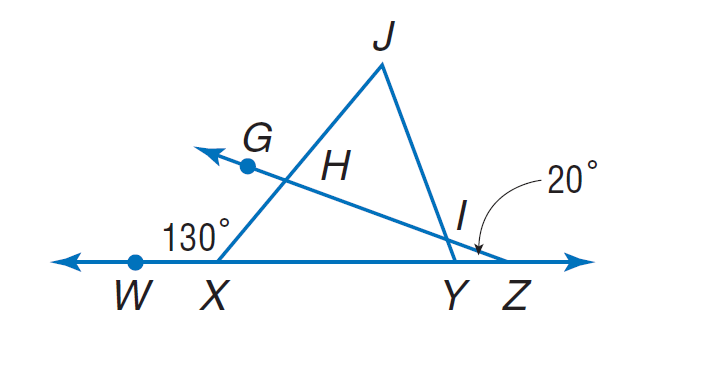Answer the mathemtical geometry problem and directly provide the correct option letter.
Question: If \frac { I J } { X J } = \frac { H J } { Y J }, m \angle W X J = 130 and m \angle W Z G = 20, find m \angle J H I.
Choices: A: 65 B: 70 C: 80 D: 85 B 